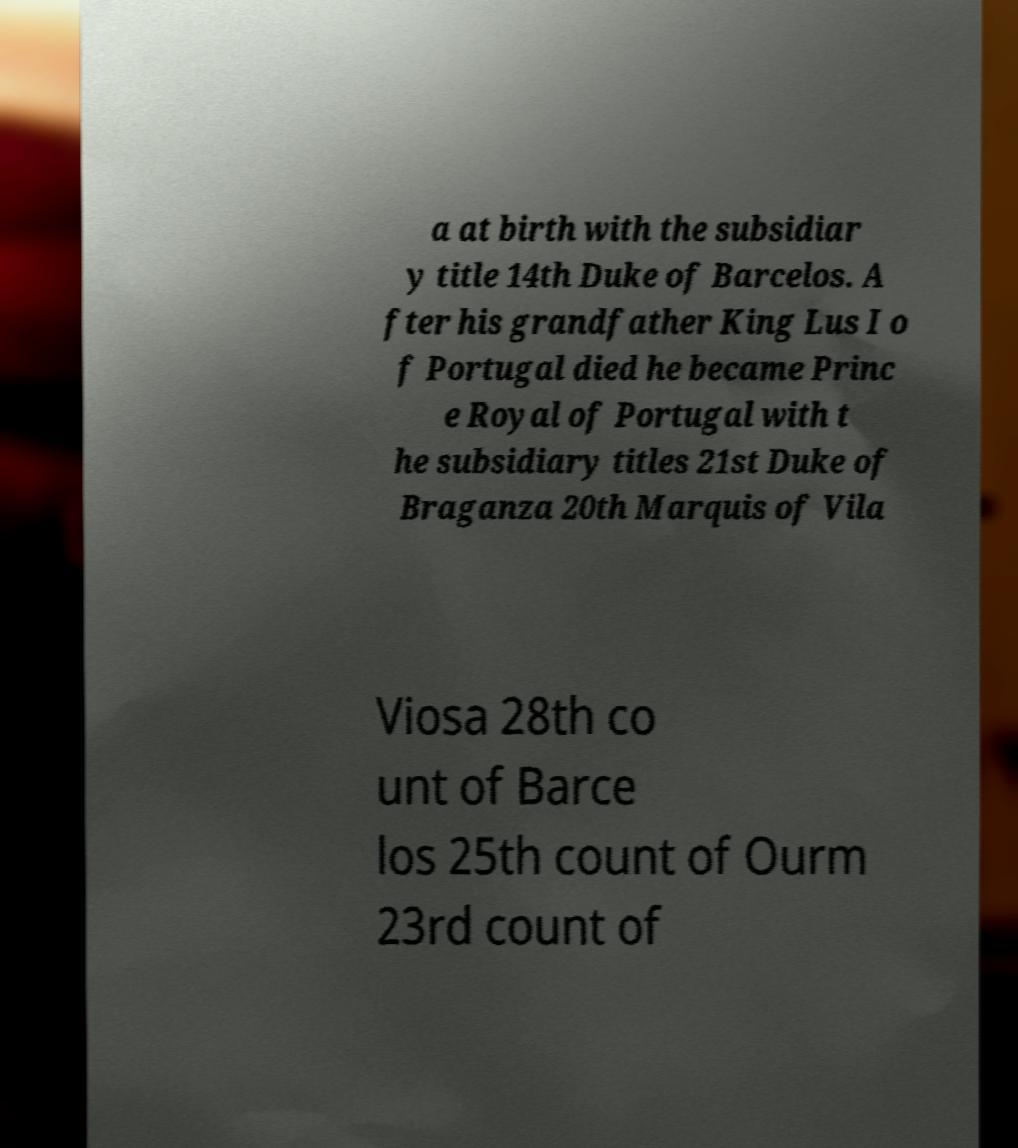Please identify and transcribe the text found in this image. a at birth with the subsidiar y title 14th Duke of Barcelos. A fter his grandfather King Lus I o f Portugal died he became Princ e Royal of Portugal with t he subsidiary titles 21st Duke of Braganza 20th Marquis of Vila Viosa 28th co unt of Barce los 25th count of Ourm 23rd count of 